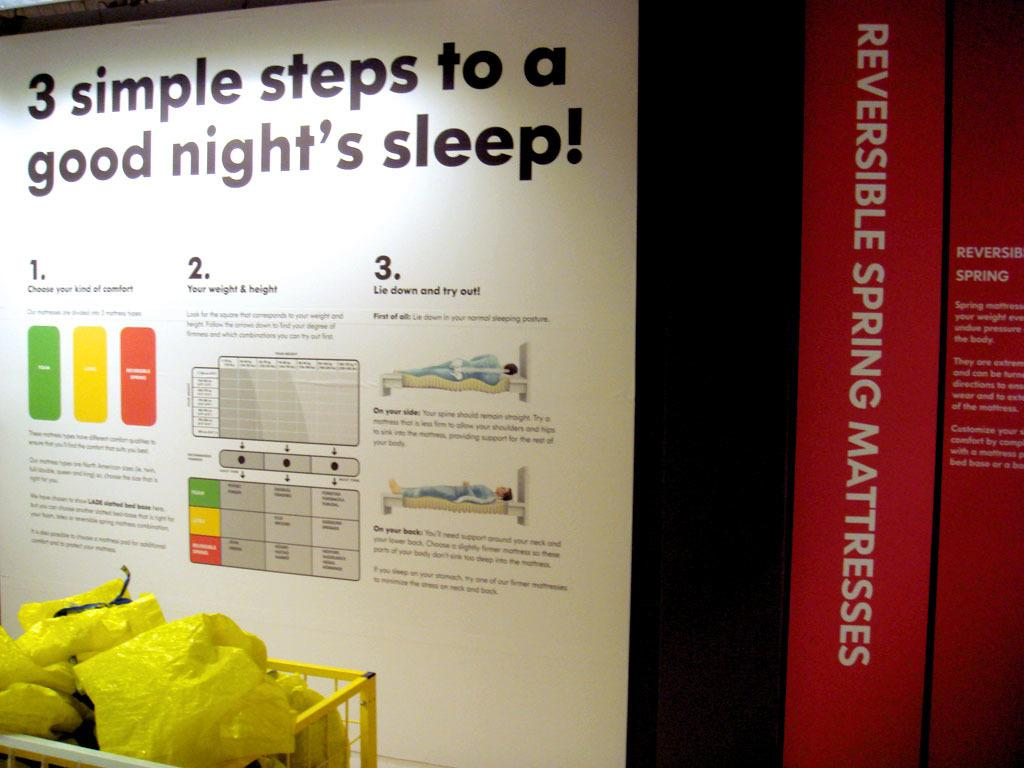Provide a one-sentence caption for the provided image. Yellow bags of trash are in front of a flyer instructing 3 steps for good sleep. 